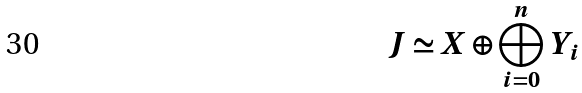Convert formula to latex. <formula><loc_0><loc_0><loc_500><loc_500>J \simeq X \oplus \bigoplus _ { i = 0 } ^ { n } Y _ { i }</formula> 